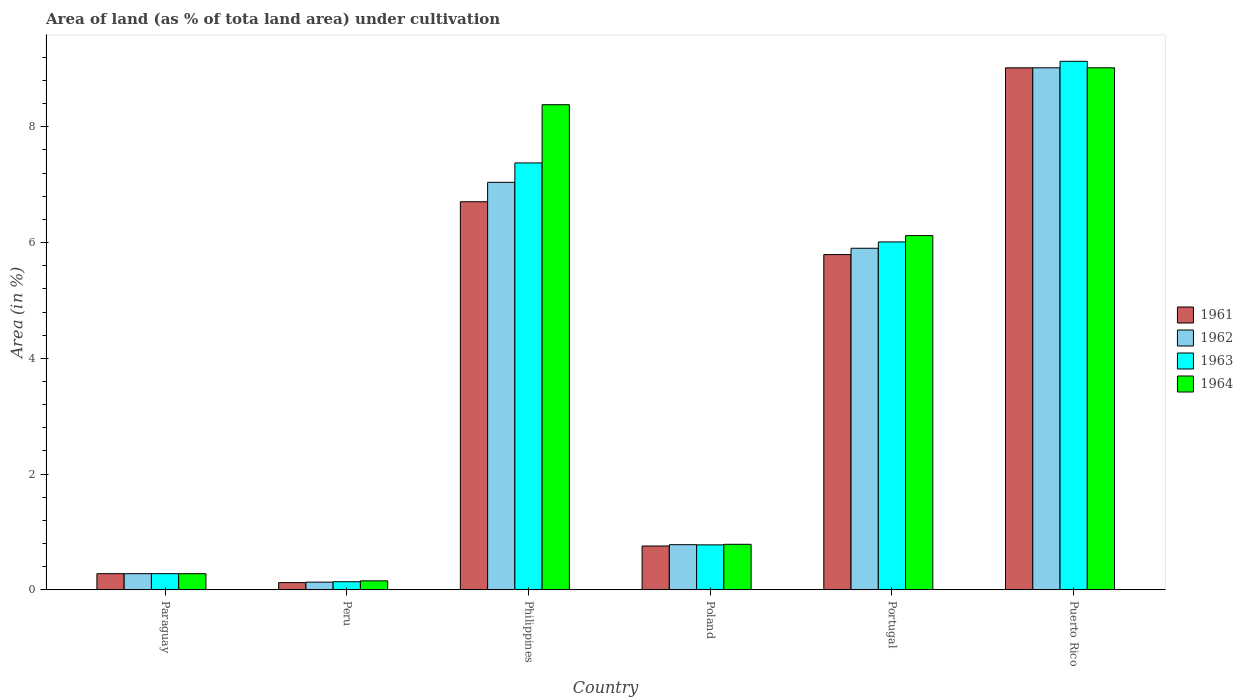How many different coloured bars are there?
Your answer should be compact. 4. How many groups of bars are there?
Provide a succinct answer. 6. Are the number of bars per tick equal to the number of legend labels?
Make the answer very short. Yes. How many bars are there on the 6th tick from the left?
Your answer should be very brief. 4. What is the label of the 4th group of bars from the left?
Give a very brief answer. Poland. What is the percentage of land under cultivation in 1961 in Philippines?
Your answer should be compact. 6.71. Across all countries, what is the maximum percentage of land under cultivation in 1963?
Your answer should be compact. 9.13. Across all countries, what is the minimum percentage of land under cultivation in 1964?
Keep it short and to the point. 0.16. In which country was the percentage of land under cultivation in 1961 maximum?
Offer a very short reply. Puerto Rico. In which country was the percentage of land under cultivation in 1964 minimum?
Give a very brief answer. Peru. What is the total percentage of land under cultivation in 1963 in the graph?
Make the answer very short. 23.72. What is the difference between the percentage of land under cultivation in 1964 in Paraguay and that in Philippines?
Make the answer very short. -8.1. What is the difference between the percentage of land under cultivation in 1961 in Portugal and the percentage of land under cultivation in 1964 in Puerto Rico?
Ensure brevity in your answer.  -3.23. What is the average percentage of land under cultivation in 1961 per country?
Make the answer very short. 3.78. What is the difference between the percentage of land under cultivation of/in 1964 and percentage of land under cultivation of/in 1962 in Peru?
Your response must be concise. 0.02. What is the ratio of the percentage of land under cultivation in 1961 in Peru to that in Philippines?
Ensure brevity in your answer.  0.02. What is the difference between the highest and the second highest percentage of land under cultivation in 1961?
Keep it short and to the point. 3.23. What is the difference between the highest and the lowest percentage of land under cultivation in 1963?
Offer a terse response. 8.99. In how many countries, is the percentage of land under cultivation in 1962 greater than the average percentage of land under cultivation in 1962 taken over all countries?
Give a very brief answer. 3. Is the sum of the percentage of land under cultivation in 1962 in Portugal and Puerto Rico greater than the maximum percentage of land under cultivation in 1961 across all countries?
Provide a short and direct response. Yes. What does the 1st bar from the left in Philippines represents?
Your answer should be very brief. 1961. What does the 3rd bar from the right in Puerto Rico represents?
Your response must be concise. 1962. Is it the case that in every country, the sum of the percentage of land under cultivation in 1963 and percentage of land under cultivation in 1962 is greater than the percentage of land under cultivation in 1964?
Provide a succinct answer. Yes. Are all the bars in the graph horizontal?
Keep it short and to the point. No. What is the difference between two consecutive major ticks on the Y-axis?
Provide a short and direct response. 2. Does the graph contain any zero values?
Your answer should be compact. No. Does the graph contain grids?
Provide a short and direct response. No. What is the title of the graph?
Offer a terse response. Area of land (as % of tota land area) under cultivation. What is the label or title of the Y-axis?
Provide a short and direct response. Area (in %). What is the Area (in %) in 1961 in Paraguay?
Make the answer very short. 0.28. What is the Area (in %) of 1962 in Paraguay?
Make the answer very short. 0.28. What is the Area (in %) of 1963 in Paraguay?
Make the answer very short. 0.28. What is the Area (in %) in 1964 in Paraguay?
Give a very brief answer. 0.28. What is the Area (in %) of 1962 in Peru?
Your response must be concise. 0.13. What is the Area (in %) of 1963 in Peru?
Make the answer very short. 0.14. What is the Area (in %) in 1964 in Peru?
Your answer should be very brief. 0.16. What is the Area (in %) in 1961 in Philippines?
Your response must be concise. 6.71. What is the Area (in %) of 1962 in Philippines?
Offer a very short reply. 7.04. What is the Area (in %) in 1963 in Philippines?
Your answer should be very brief. 7.38. What is the Area (in %) of 1964 in Philippines?
Make the answer very short. 8.38. What is the Area (in %) in 1961 in Poland?
Provide a succinct answer. 0.76. What is the Area (in %) of 1962 in Poland?
Offer a terse response. 0.78. What is the Area (in %) in 1963 in Poland?
Ensure brevity in your answer.  0.78. What is the Area (in %) of 1964 in Poland?
Offer a very short reply. 0.79. What is the Area (in %) of 1961 in Portugal?
Your response must be concise. 5.79. What is the Area (in %) of 1962 in Portugal?
Your response must be concise. 5.9. What is the Area (in %) in 1963 in Portugal?
Ensure brevity in your answer.  6.01. What is the Area (in %) in 1964 in Portugal?
Your answer should be very brief. 6.12. What is the Area (in %) of 1961 in Puerto Rico?
Give a very brief answer. 9.02. What is the Area (in %) in 1962 in Puerto Rico?
Your answer should be very brief. 9.02. What is the Area (in %) in 1963 in Puerto Rico?
Your answer should be very brief. 9.13. What is the Area (in %) of 1964 in Puerto Rico?
Your answer should be very brief. 9.02. Across all countries, what is the maximum Area (in %) of 1961?
Provide a short and direct response. 9.02. Across all countries, what is the maximum Area (in %) in 1962?
Offer a very short reply. 9.02. Across all countries, what is the maximum Area (in %) of 1963?
Provide a succinct answer. 9.13. Across all countries, what is the maximum Area (in %) in 1964?
Keep it short and to the point. 9.02. Across all countries, what is the minimum Area (in %) of 1962?
Keep it short and to the point. 0.13. Across all countries, what is the minimum Area (in %) of 1963?
Your answer should be compact. 0.14. Across all countries, what is the minimum Area (in %) of 1964?
Your answer should be very brief. 0.16. What is the total Area (in %) in 1961 in the graph?
Provide a succinct answer. 22.68. What is the total Area (in %) of 1962 in the graph?
Give a very brief answer. 23.15. What is the total Area (in %) in 1963 in the graph?
Provide a succinct answer. 23.72. What is the total Area (in %) of 1964 in the graph?
Give a very brief answer. 24.74. What is the difference between the Area (in %) in 1961 in Paraguay and that in Peru?
Give a very brief answer. 0.15. What is the difference between the Area (in %) of 1962 in Paraguay and that in Peru?
Give a very brief answer. 0.15. What is the difference between the Area (in %) in 1963 in Paraguay and that in Peru?
Make the answer very short. 0.14. What is the difference between the Area (in %) of 1964 in Paraguay and that in Peru?
Ensure brevity in your answer.  0.12. What is the difference between the Area (in %) of 1961 in Paraguay and that in Philippines?
Ensure brevity in your answer.  -6.43. What is the difference between the Area (in %) in 1962 in Paraguay and that in Philippines?
Offer a very short reply. -6.76. What is the difference between the Area (in %) in 1963 in Paraguay and that in Philippines?
Your answer should be compact. -7.1. What is the difference between the Area (in %) of 1964 in Paraguay and that in Philippines?
Give a very brief answer. -8.1. What is the difference between the Area (in %) of 1961 in Paraguay and that in Poland?
Make the answer very short. -0.48. What is the difference between the Area (in %) in 1962 in Paraguay and that in Poland?
Your response must be concise. -0.5. What is the difference between the Area (in %) in 1963 in Paraguay and that in Poland?
Offer a very short reply. -0.5. What is the difference between the Area (in %) of 1964 in Paraguay and that in Poland?
Ensure brevity in your answer.  -0.51. What is the difference between the Area (in %) of 1961 in Paraguay and that in Portugal?
Keep it short and to the point. -5.51. What is the difference between the Area (in %) in 1962 in Paraguay and that in Portugal?
Keep it short and to the point. -5.62. What is the difference between the Area (in %) of 1963 in Paraguay and that in Portugal?
Provide a succinct answer. -5.73. What is the difference between the Area (in %) in 1964 in Paraguay and that in Portugal?
Offer a very short reply. -5.84. What is the difference between the Area (in %) of 1961 in Paraguay and that in Puerto Rico?
Your response must be concise. -8.74. What is the difference between the Area (in %) in 1962 in Paraguay and that in Puerto Rico?
Make the answer very short. -8.74. What is the difference between the Area (in %) of 1963 in Paraguay and that in Puerto Rico?
Keep it short and to the point. -8.85. What is the difference between the Area (in %) of 1964 in Paraguay and that in Puerto Rico?
Offer a very short reply. -8.74. What is the difference between the Area (in %) in 1961 in Peru and that in Philippines?
Give a very brief answer. -6.58. What is the difference between the Area (in %) of 1962 in Peru and that in Philippines?
Provide a succinct answer. -6.91. What is the difference between the Area (in %) of 1963 in Peru and that in Philippines?
Provide a short and direct response. -7.24. What is the difference between the Area (in %) of 1964 in Peru and that in Philippines?
Provide a short and direct response. -8.23. What is the difference between the Area (in %) in 1961 in Peru and that in Poland?
Your answer should be compact. -0.63. What is the difference between the Area (in %) of 1962 in Peru and that in Poland?
Your answer should be very brief. -0.65. What is the difference between the Area (in %) of 1963 in Peru and that in Poland?
Provide a succinct answer. -0.64. What is the difference between the Area (in %) in 1964 in Peru and that in Poland?
Give a very brief answer. -0.63. What is the difference between the Area (in %) in 1961 in Peru and that in Portugal?
Offer a terse response. -5.67. What is the difference between the Area (in %) of 1962 in Peru and that in Portugal?
Provide a succinct answer. -5.77. What is the difference between the Area (in %) of 1963 in Peru and that in Portugal?
Make the answer very short. -5.87. What is the difference between the Area (in %) of 1964 in Peru and that in Portugal?
Offer a terse response. -5.96. What is the difference between the Area (in %) in 1961 in Peru and that in Puerto Rico?
Provide a short and direct response. -8.89. What is the difference between the Area (in %) in 1962 in Peru and that in Puerto Rico?
Keep it short and to the point. -8.89. What is the difference between the Area (in %) of 1963 in Peru and that in Puerto Rico?
Offer a terse response. -8.99. What is the difference between the Area (in %) in 1964 in Peru and that in Puerto Rico?
Offer a very short reply. -8.86. What is the difference between the Area (in %) of 1961 in Philippines and that in Poland?
Make the answer very short. 5.95. What is the difference between the Area (in %) of 1962 in Philippines and that in Poland?
Offer a terse response. 6.26. What is the difference between the Area (in %) of 1963 in Philippines and that in Poland?
Keep it short and to the point. 6.6. What is the difference between the Area (in %) in 1964 in Philippines and that in Poland?
Provide a short and direct response. 7.6. What is the difference between the Area (in %) in 1961 in Philippines and that in Portugal?
Offer a terse response. 0.91. What is the difference between the Area (in %) of 1962 in Philippines and that in Portugal?
Give a very brief answer. 1.14. What is the difference between the Area (in %) of 1963 in Philippines and that in Portugal?
Keep it short and to the point. 1.37. What is the difference between the Area (in %) in 1964 in Philippines and that in Portugal?
Your answer should be very brief. 2.26. What is the difference between the Area (in %) of 1961 in Philippines and that in Puerto Rico?
Keep it short and to the point. -2.31. What is the difference between the Area (in %) in 1962 in Philippines and that in Puerto Rico?
Provide a succinct answer. -1.98. What is the difference between the Area (in %) of 1963 in Philippines and that in Puerto Rico?
Make the answer very short. -1.76. What is the difference between the Area (in %) in 1964 in Philippines and that in Puerto Rico?
Offer a very short reply. -0.64. What is the difference between the Area (in %) in 1961 in Poland and that in Portugal?
Offer a terse response. -5.03. What is the difference between the Area (in %) of 1962 in Poland and that in Portugal?
Give a very brief answer. -5.12. What is the difference between the Area (in %) of 1963 in Poland and that in Portugal?
Your answer should be very brief. -5.23. What is the difference between the Area (in %) in 1964 in Poland and that in Portugal?
Keep it short and to the point. -5.33. What is the difference between the Area (in %) of 1961 in Poland and that in Puerto Rico?
Provide a short and direct response. -8.26. What is the difference between the Area (in %) of 1962 in Poland and that in Puerto Rico?
Make the answer very short. -8.24. What is the difference between the Area (in %) in 1963 in Poland and that in Puerto Rico?
Your answer should be very brief. -8.35. What is the difference between the Area (in %) of 1964 in Poland and that in Puerto Rico?
Make the answer very short. -8.23. What is the difference between the Area (in %) of 1961 in Portugal and that in Puerto Rico?
Provide a succinct answer. -3.23. What is the difference between the Area (in %) of 1962 in Portugal and that in Puerto Rico?
Provide a succinct answer. -3.12. What is the difference between the Area (in %) in 1963 in Portugal and that in Puerto Rico?
Provide a short and direct response. -3.12. What is the difference between the Area (in %) of 1964 in Portugal and that in Puerto Rico?
Make the answer very short. -2.9. What is the difference between the Area (in %) of 1961 in Paraguay and the Area (in %) of 1962 in Peru?
Your answer should be very brief. 0.15. What is the difference between the Area (in %) of 1961 in Paraguay and the Area (in %) of 1963 in Peru?
Offer a very short reply. 0.14. What is the difference between the Area (in %) of 1961 in Paraguay and the Area (in %) of 1964 in Peru?
Your answer should be very brief. 0.12. What is the difference between the Area (in %) in 1962 in Paraguay and the Area (in %) in 1963 in Peru?
Provide a short and direct response. 0.14. What is the difference between the Area (in %) in 1962 in Paraguay and the Area (in %) in 1964 in Peru?
Offer a very short reply. 0.12. What is the difference between the Area (in %) in 1963 in Paraguay and the Area (in %) in 1964 in Peru?
Your answer should be compact. 0.12. What is the difference between the Area (in %) in 1961 in Paraguay and the Area (in %) in 1962 in Philippines?
Make the answer very short. -6.76. What is the difference between the Area (in %) in 1961 in Paraguay and the Area (in %) in 1963 in Philippines?
Your answer should be compact. -7.1. What is the difference between the Area (in %) in 1961 in Paraguay and the Area (in %) in 1964 in Philippines?
Your response must be concise. -8.1. What is the difference between the Area (in %) in 1962 in Paraguay and the Area (in %) in 1963 in Philippines?
Ensure brevity in your answer.  -7.1. What is the difference between the Area (in %) of 1962 in Paraguay and the Area (in %) of 1964 in Philippines?
Offer a terse response. -8.1. What is the difference between the Area (in %) of 1963 in Paraguay and the Area (in %) of 1964 in Philippines?
Give a very brief answer. -8.1. What is the difference between the Area (in %) in 1961 in Paraguay and the Area (in %) in 1962 in Poland?
Your response must be concise. -0.5. What is the difference between the Area (in %) in 1961 in Paraguay and the Area (in %) in 1963 in Poland?
Give a very brief answer. -0.5. What is the difference between the Area (in %) of 1961 in Paraguay and the Area (in %) of 1964 in Poland?
Your answer should be very brief. -0.51. What is the difference between the Area (in %) in 1962 in Paraguay and the Area (in %) in 1963 in Poland?
Ensure brevity in your answer.  -0.5. What is the difference between the Area (in %) of 1962 in Paraguay and the Area (in %) of 1964 in Poland?
Provide a short and direct response. -0.51. What is the difference between the Area (in %) in 1963 in Paraguay and the Area (in %) in 1964 in Poland?
Your answer should be compact. -0.51. What is the difference between the Area (in %) of 1961 in Paraguay and the Area (in %) of 1962 in Portugal?
Your answer should be very brief. -5.62. What is the difference between the Area (in %) of 1961 in Paraguay and the Area (in %) of 1963 in Portugal?
Offer a terse response. -5.73. What is the difference between the Area (in %) in 1961 in Paraguay and the Area (in %) in 1964 in Portugal?
Your response must be concise. -5.84. What is the difference between the Area (in %) of 1962 in Paraguay and the Area (in %) of 1963 in Portugal?
Offer a terse response. -5.73. What is the difference between the Area (in %) in 1962 in Paraguay and the Area (in %) in 1964 in Portugal?
Ensure brevity in your answer.  -5.84. What is the difference between the Area (in %) of 1963 in Paraguay and the Area (in %) of 1964 in Portugal?
Your answer should be very brief. -5.84. What is the difference between the Area (in %) of 1961 in Paraguay and the Area (in %) of 1962 in Puerto Rico?
Offer a very short reply. -8.74. What is the difference between the Area (in %) in 1961 in Paraguay and the Area (in %) in 1963 in Puerto Rico?
Your response must be concise. -8.85. What is the difference between the Area (in %) in 1961 in Paraguay and the Area (in %) in 1964 in Puerto Rico?
Your response must be concise. -8.74. What is the difference between the Area (in %) in 1962 in Paraguay and the Area (in %) in 1963 in Puerto Rico?
Your response must be concise. -8.85. What is the difference between the Area (in %) of 1962 in Paraguay and the Area (in %) of 1964 in Puerto Rico?
Ensure brevity in your answer.  -8.74. What is the difference between the Area (in %) of 1963 in Paraguay and the Area (in %) of 1964 in Puerto Rico?
Keep it short and to the point. -8.74. What is the difference between the Area (in %) of 1961 in Peru and the Area (in %) of 1962 in Philippines?
Keep it short and to the point. -6.92. What is the difference between the Area (in %) in 1961 in Peru and the Area (in %) in 1963 in Philippines?
Offer a very short reply. -7.25. What is the difference between the Area (in %) in 1961 in Peru and the Area (in %) in 1964 in Philippines?
Your answer should be very brief. -8.26. What is the difference between the Area (in %) in 1962 in Peru and the Area (in %) in 1963 in Philippines?
Provide a short and direct response. -7.24. What is the difference between the Area (in %) in 1962 in Peru and the Area (in %) in 1964 in Philippines?
Make the answer very short. -8.25. What is the difference between the Area (in %) in 1963 in Peru and the Area (in %) in 1964 in Philippines?
Your answer should be compact. -8.24. What is the difference between the Area (in %) of 1961 in Peru and the Area (in %) of 1962 in Poland?
Your response must be concise. -0.66. What is the difference between the Area (in %) in 1961 in Peru and the Area (in %) in 1963 in Poland?
Keep it short and to the point. -0.65. What is the difference between the Area (in %) of 1961 in Peru and the Area (in %) of 1964 in Poland?
Offer a terse response. -0.66. What is the difference between the Area (in %) of 1962 in Peru and the Area (in %) of 1963 in Poland?
Offer a very short reply. -0.64. What is the difference between the Area (in %) in 1962 in Peru and the Area (in %) in 1964 in Poland?
Make the answer very short. -0.65. What is the difference between the Area (in %) in 1963 in Peru and the Area (in %) in 1964 in Poland?
Provide a short and direct response. -0.65. What is the difference between the Area (in %) of 1961 in Peru and the Area (in %) of 1962 in Portugal?
Provide a succinct answer. -5.78. What is the difference between the Area (in %) of 1961 in Peru and the Area (in %) of 1963 in Portugal?
Give a very brief answer. -5.89. What is the difference between the Area (in %) of 1961 in Peru and the Area (in %) of 1964 in Portugal?
Provide a succinct answer. -6. What is the difference between the Area (in %) in 1962 in Peru and the Area (in %) in 1963 in Portugal?
Provide a succinct answer. -5.88. What is the difference between the Area (in %) in 1962 in Peru and the Area (in %) in 1964 in Portugal?
Provide a short and direct response. -5.99. What is the difference between the Area (in %) in 1963 in Peru and the Area (in %) in 1964 in Portugal?
Provide a short and direct response. -5.98. What is the difference between the Area (in %) of 1961 in Peru and the Area (in %) of 1962 in Puerto Rico?
Your response must be concise. -8.89. What is the difference between the Area (in %) of 1961 in Peru and the Area (in %) of 1963 in Puerto Rico?
Give a very brief answer. -9.01. What is the difference between the Area (in %) of 1961 in Peru and the Area (in %) of 1964 in Puerto Rico?
Provide a succinct answer. -8.89. What is the difference between the Area (in %) in 1962 in Peru and the Area (in %) in 1963 in Puerto Rico?
Offer a terse response. -9. What is the difference between the Area (in %) in 1962 in Peru and the Area (in %) in 1964 in Puerto Rico?
Ensure brevity in your answer.  -8.89. What is the difference between the Area (in %) in 1963 in Peru and the Area (in %) in 1964 in Puerto Rico?
Ensure brevity in your answer.  -8.88. What is the difference between the Area (in %) in 1961 in Philippines and the Area (in %) in 1962 in Poland?
Your answer should be very brief. 5.93. What is the difference between the Area (in %) of 1961 in Philippines and the Area (in %) of 1963 in Poland?
Your answer should be compact. 5.93. What is the difference between the Area (in %) of 1961 in Philippines and the Area (in %) of 1964 in Poland?
Offer a very short reply. 5.92. What is the difference between the Area (in %) in 1962 in Philippines and the Area (in %) in 1963 in Poland?
Provide a short and direct response. 6.26. What is the difference between the Area (in %) of 1962 in Philippines and the Area (in %) of 1964 in Poland?
Give a very brief answer. 6.25. What is the difference between the Area (in %) of 1963 in Philippines and the Area (in %) of 1964 in Poland?
Your answer should be compact. 6.59. What is the difference between the Area (in %) in 1961 in Philippines and the Area (in %) in 1962 in Portugal?
Provide a short and direct response. 0.8. What is the difference between the Area (in %) of 1961 in Philippines and the Area (in %) of 1963 in Portugal?
Your answer should be very brief. 0.69. What is the difference between the Area (in %) of 1961 in Philippines and the Area (in %) of 1964 in Portugal?
Make the answer very short. 0.59. What is the difference between the Area (in %) of 1962 in Philippines and the Area (in %) of 1963 in Portugal?
Your response must be concise. 1.03. What is the difference between the Area (in %) in 1962 in Philippines and the Area (in %) in 1964 in Portugal?
Provide a succinct answer. 0.92. What is the difference between the Area (in %) in 1963 in Philippines and the Area (in %) in 1964 in Portugal?
Your answer should be very brief. 1.26. What is the difference between the Area (in %) in 1961 in Philippines and the Area (in %) in 1962 in Puerto Rico?
Provide a short and direct response. -2.31. What is the difference between the Area (in %) of 1961 in Philippines and the Area (in %) of 1963 in Puerto Rico?
Keep it short and to the point. -2.43. What is the difference between the Area (in %) in 1961 in Philippines and the Area (in %) in 1964 in Puerto Rico?
Ensure brevity in your answer.  -2.31. What is the difference between the Area (in %) in 1962 in Philippines and the Area (in %) in 1963 in Puerto Rico?
Offer a terse response. -2.09. What is the difference between the Area (in %) in 1962 in Philippines and the Area (in %) in 1964 in Puerto Rico?
Give a very brief answer. -1.98. What is the difference between the Area (in %) of 1963 in Philippines and the Area (in %) of 1964 in Puerto Rico?
Offer a terse response. -1.64. What is the difference between the Area (in %) in 1961 in Poland and the Area (in %) in 1962 in Portugal?
Your answer should be very brief. -5.14. What is the difference between the Area (in %) of 1961 in Poland and the Area (in %) of 1963 in Portugal?
Provide a succinct answer. -5.25. What is the difference between the Area (in %) of 1961 in Poland and the Area (in %) of 1964 in Portugal?
Offer a very short reply. -5.36. What is the difference between the Area (in %) of 1962 in Poland and the Area (in %) of 1963 in Portugal?
Provide a succinct answer. -5.23. What is the difference between the Area (in %) in 1962 in Poland and the Area (in %) in 1964 in Portugal?
Give a very brief answer. -5.34. What is the difference between the Area (in %) in 1963 in Poland and the Area (in %) in 1964 in Portugal?
Make the answer very short. -5.34. What is the difference between the Area (in %) in 1961 in Poland and the Area (in %) in 1962 in Puerto Rico?
Your answer should be compact. -8.26. What is the difference between the Area (in %) in 1961 in Poland and the Area (in %) in 1963 in Puerto Rico?
Offer a very short reply. -8.37. What is the difference between the Area (in %) in 1961 in Poland and the Area (in %) in 1964 in Puerto Rico?
Your response must be concise. -8.26. What is the difference between the Area (in %) of 1962 in Poland and the Area (in %) of 1963 in Puerto Rico?
Ensure brevity in your answer.  -8.35. What is the difference between the Area (in %) in 1962 in Poland and the Area (in %) in 1964 in Puerto Rico?
Offer a terse response. -8.24. What is the difference between the Area (in %) of 1963 in Poland and the Area (in %) of 1964 in Puerto Rico?
Keep it short and to the point. -8.24. What is the difference between the Area (in %) in 1961 in Portugal and the Area (in %) in 1962 in Puerto Rico?
Offer a very short reply. -3.23. What is the difference between the Area (in %) in 1961 in Portugal and the Area (in %) in 1963 in Puerto Rico?
Your answer should be very brief. -3.34. What is the difference between the Area (in %) in 1961 in Portugal and the Area (in %) in 1964 in Puerto Rico?
Give a very brief answer. -3.23. What is the difference between the Area (in %) of 1962 in Portugal and the Area (in %) of 1963 in Puerto Rico?
Your answer should be compact. -3.23. What is the difference between the Area (in %) in 1962 in Portugal and the Area (in %) in 1964 in Puerto Rico?
Provide a succinct answer. -3.12. What is the difference between the Area (in %) in 1963 in Portugal and the Area (in %) in 1964 in Puerto Rico?
Your answer should be compact. -3.01. What is the average Area (in %) of 1961 per country?
Offer a terse response. 3.78. What is the average Area (in %) in 1962 per country?
Provide a short and direct response. 3.86. What is the average Area (in %) in 1963 per country?
Ensure brevity in your answer.  3.95. What is the average Area (in %) in 1964 per country?
Ensure brevity in your answer.  4.12. What is the difference between the Area (in %) of 1961 and Area (in %) of 1962 in Paraguay?
Offer a terse response. 0. What is the difference between the Area (in %) in 1961 and Area (in %) in 1964 in Paraguay?
Offer a terse response. 0. What is the difference between the Area (in %) of 1961 and Area (in %) of 1962 in Peru?
Make the answer very short. -0.01. What is the difference between the Area (in %) in 1961 and Area (in %) in 1963 in Peru?
Make the answer very short. -0.02. What is the difference between the Area (in %) in 1961 and Area (in %) in 1964 in Peru?
Give a very brief answer. -0.03. What is the difference between the Area (in %) of 1962 and Area (in %) of 1963 in Peru?
Offer a very short reply. -0.01. What is the difference between the Area (in %) in 1962 and Area (in %) in 1964 in Peru?
Provide a short and direct response. -0.02. What is the difference between the Area (in %) of 1963 and Area (in %) of 1964 in Peru?
Your answer should be compact. -0.01. What is the difference between the Area (in %) of 1961 and Area (in %) of 1962 in Philippines?
Offer a terse response. -0.34. What is the difference between the Area (in %) of 1961 and Area (in %) of 1963 in Philippines?
Your answer should be compact. -0.67. What is the difference between the Area (in %) of 1961 and Area (in %) of 1964 in Philippines?
Offer a terse response. -1.68. What is the difference between the Area (in %) in 1962 and Area (in %) in 1963 in Philippines?
Ensure brevity in your answer.  -0.34. What is the difference between the Area (in %) of 1962 and Area (in %) of 1964 in Philippines?
Your answer should be compact. -1.34. What is the difference between the Area (in %) of 1963 and Area (in %) of 1964 in Philippines?
Make the answer very short. -1.01. What is the difference between the Area (in %) in 1961 and Area (in %) in 1962 in Poland?
Provide a short and direct response. -0.02. What is the difference between the Area (in %) in 1961 and Area (in %) in 1963 in Poland?
Ensure brevity in your answer.  -0.02. What is the difference between the Area (in %) of 1961 and Area (in %) of 1964 in Poland?
Make the answer very short. -0.03. What is the difference between the Area (in %) in 1962 and Area (in %) in 1963 in Poland?
Keep it short and to the point. 0. What is the difference between the Area (in %) of 1962 and Area (in %) of 1964 in Poland?
Ensure brevity in your answer.  -0.01. What is the difference between the Area (in %) of 1963 and Area (in %) of 1964 in Poland?
Your response must be concise. -0.01. What is the difference between the Area (in %) of 1961 and Area (in %) of 1962 in Portugal?
Offer a terse response. -0.11. What is the difference between the Area (in %) in 1961 and Area (in %) in 1963 in Portugal?
Your answer should be compact. -0.22. What is the difference between the Area (in %) in 1961 and Area (in %) in 1964 in Portugal?
Offer a very short reply. -0.33. What is the difference between the Area (in %) in 1962 and Area (in %) in 1963 in Portugal?
Make the answer very short. -0.11. What is the difference between the Area (in %) in 1962 and Area (in %) in 1964 in Portugal?
Provide a succinct answer. -0.22. What is the difference between the Area (in %) of 1963 and Area (in %) of 1964 in Portugal?
Provide a succinct answer. -0.11. What is the difference between the Area (in %) in 1961 and Area (in %) in 1962 in Puerto Rico?
Offer a terse response. 0. What is the difference between the Area (in %) of 1961 and Area (in %) of 1963 in Puerto Rico?
Your answer should be very brief. -0.11. What is the difference between the Area (in %) in 1961 and Area (in %) in 1964 in Puerto Rico?
Your response must be concise. 0. What is the difference between the Area (in %) of 1962 and Area (in %) of 1963 in Puerto Rico?
Ensure brevity in your answer.  -0.11. What is the difference between the Area (in %) in 1963 and Area (in %) in 1964 in Puerto Rico?
Your answer should be compact. 0.11. What is the ratio of the Area (in %) in 1961 in Paraguay to that in Peru?
Keep it short and to the point. 2.24. What is the ratio of the Area (in %) in 1962 in Paraguay to that in Peru?
Provide a succinct answer. 2.1. What is the ratio of the Area (in %) in 1963 in Paraguay to that in Peru?
Your response must be concise. 1.99. What is the ratio of the Area (in %) in 1964 in Paraguay to that in Peru?
Your answer should be compact. 1.8. What is the ratio of the Area (in %) of 1961 in Paraguay to that in Philippines?
Keep it short and to the point. 0.04. What is the ratio of the Area (in %) in 1962 in Paraguay to that in Philippines?
Provide a succinct answer. 0.04. What is the ratio of the Area (in %) in 1963 in Paraguay to that in Philippines?
Provide a short and direct response. 0.04. What is the ratio of the Area (in %) in 1964 in Paraguay to that in Philippines?
Make the answer very short. 0.03. What is the ratio of the Area (in %) of 1961 in Paraguay to that in Poland?
Give a very brief answer. 0.37. What is the ratio of the Area (in %) of 1962 in Paraguay to that in Poland?
Provide a short and direct response. 0.36. What is the ratio of the Area (in %) of 1963 in Paraguay to that in Poland?
Your answer should be very brief. 0.36. What is the ratio of the Area (in %) in 1964 in Paraguay to that in Poland?
Your answer should be compact. 0.36. What is the ratio of the Area (in %) in 1961 in Paraguay to that in Portugal?
Your response must be concise. 0.05. What is the ratio of the Area (in %) of 1962 in Paraguay to that in Portugal?
Your answer should be very brief. 0.05. What is the ratio of the Area (in %) in 1963 in Paraguay to that in Portugal?
Give a very brief answer. 0.05. What is the ratio of the Area (in %) in 1964 in Paraguay to that in Portugal?
Provide a succinct answer. 0.05. What is the ratio of the Area (in %) in 1961 in Paraguay to that in Puerto Rico?
Your answer should be very brief. 0.03. What is the ratio of the Area (in %) of 1962 in Paraguay to that in Puerto Rico?
Keep it short and to the point. 0.03. What is the ratio of the Area (in %) in 1963 in Paraguay to that in Puerto Rico?
Keep it short and to the point. 0.03. What is the ratio of the Area (in %) of 1964 in Paraguay to that in Puerto Rico?
Ensure brevity in your answer.  0.03. What is the ratio of the Area (in %) of 1961 in Peru to that in Philippines?
Ensure brevity in your answer.  0.02. What is the ratio of the Area (in %) in 1962 in Peru to that in Philippines?
Make the answer very short. 0.02. What is the ratio of the Area (in %) in 1963 in Peru to that in Philippines?
Your response must be concise. 0.02. What is the ratio of the Area (in %) in 1964 in Peru to that in Philippines?
Ensure brevity in your answer.  0.02. What is the ratio of the Area (in %) in 1961 in Peru to that in Poland?
Offer a very short reply. 0.17. What is the ratio of the Area (in %) in 1962 in Peru to that in Poland?
Your answer should be very brief. 0.17. What is the ratio of the Area (in %) of 1963 in Peru to that in Poland?
Provide a short and direct response. 0.18. What is the ratio of the Area (in %) in 1964 in Peru to that in Poland?
Offer a very short reply. 0.2. What is the ratio of the Area (in %) of 1961 in Peru to that in Portugal?
Ensure brevity in your answer.  0.02. What is the ratio of the Area (in %) in 1962 in Peru to that in Portugal?
Provide a short and direct response. 0.02. What is the ratio of the Area (in %) in 1963 in Peru to that in Portugal?
Keep it short and to the point. 0.02. What is the ratio of the Area (in %) in 1964 in Peru to that in Portugal?
Provide a short and direct response. 0.03. What is the ratio of the Area (in %) of 1961 in Peru to that in Puerto Rico?
Offer a terse response. 0.01. What is the ratio of the Area (in %) of 1962 in Peru to that in Puerto Rico?
Keep it short and to the point. 0.01. What is the ratio of the Area (in %) of 1963 in Peru to that in Puerto Rico?
Provide a short and direct response. 0.02. What is the ratio of the Area (in %) in 1964 in Peru to that in Puerto Rico?
Keep it short and to the point. 0.02. What is the ratio of the Area (in %) in 1961 in Philippines to that in Poland?
Your response must be concise. 8.85. What is the ratio of the Area (in %) of 1962 in Philippines to that in Poland?
Ensure brevity in your answer.  9.02. What is the ratio of the Area (in %) in 1963 in Philippines to that in Poland?
Provide a succinct answer. 9.49. What is the ratio of the Area (in %) in 1964 in Philippines to that in Poland?
Offer a very short reply. 10.65. What is the ratio of the Area (in %) in 1961 in Philippines to that in Portugal?
Offer a very short reply. 1.16. What is the ratio of the Area (in %) of 1962 in Philippines to that in Portugal?
Keep it short and to the point. 1.19. What is the ratio of the Area (in %) in 1963 in Philippines to that in Portugal?
Your answer should be very brief. 1.23. What is the ratio of the Area (in %) in 1964 in Philippines to that in Portugal?
Provide a short and direct response. 1.37. What is the ratio of the Area (in %) in 1961 in Philippines to that in Puerto Rico?
Give a very brief answer. 0.74. What is the ratio of the Area (in %) in 1962 in Philippines to that in Puerto Rico?
Give a very brief answer. 0.78. What is the ratio of the Area (in %) of 1963 in Philippines to that in Puerto Rico?
Your answer should be compact. 0.81. What is the ratio of the Area (in %) in 1964 in Philippines to that in Puerto Rico?
Provide a short and direct response. 0.93. What is the ratio of the Area (in %) of 1961 in Poland to that in Portugal?
Your answer should be compact. 0.13. What is the ratio of the Area (in %) in 1962 in Poland to that in Portugal?
Provide a short and direct response. 0.13. What is the ratio of the Area (in %) in 1963 in Poland to that in Portugal?
Your response must be concise. 0.13. What is the ratio of the Area (in %) of 1964 in Poland to that in Portugal?
Your response must be concise. 0.13. What is the ratio of the Area (in %) in 1961 in Poland to that in Puerto Rico?
Offer a terse response. 0.08. What is the ratio of the Area (in %) of 1962 in Poland to that in Puerto Rico?
Offer a very short reply. 0.09. What is the ratio of the Area (in %) in 1963 in Poland to that in Puerto Rico?
Provide a short and direct response. 0.09. What is the ratio of the Area (in %) of 1964 in Poland to that in Puerto Rico?
Make the answer very short. 0.09. What is the ratio of the Area (in %) of 1961 in Portugal to that in Puerto Rico?
Provide a short and direct response. 0.64. What is the ratio of the Area (in %) of 1962 in Portugal to that in Puerto Rico?
Ensure brevity in your answer.  0.65. What is the ratio of the Area (in %) of 1963 in Portugal to that in Puerto Rico?
Your answer should be very brief. 0.66. What is the ratio of the Area (in %) of 1964 in Portugal to that in Puerto Rico?
Your answer should be very brief. 0.68. What is the difference between the highest and the second highest Area (in %) in 1961?
Ensure brevity in your answer.  2.31. What is the difference between the highest and the second highest Area (in %) in 1962?
Keep it short and to the point. 1.98. What is the difference between the highest and the second highest Area (in %) in 1963?
Offer a very short reply. 1.76. What is the difference between the highest and the second highest Area (in %) of 1964?
Provide a succinct answer. 0.64. What is the difference between the highest and the lowest Area (in %) of 1961?
Ensure brevity in your answer.  8.89. What is the difference between the highest and the lowest Area (in %) in 1962?
Your answer should be compact. 8.89. What is the difference between the highest and the lowest Area (in %) in 1963?
Your answer should be compact. 8.99. What is the difference between the highest and the lowest Area (in %) in 1964?
Provide a succinct answer. 8.86. 